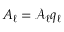Convert formula to latex. <formula><loc_0><loc_0><loc_500><loc_500>A _ { \ell } = \mathcal { A } _ { \ell } q _ { \ell }</formula> 